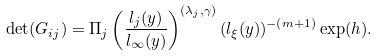<formula> <loc_0><loc_0><loc_500><loc_500>\det ( G _ { i j } ) = \Pi _ { j } \left ( \frac { l _ { j } ( y ) } { l _ { \infty } ( y ) } \right ) ^ { ( \lambda _ { j } , \gamma ) } ( l _ { \xi } ( y ) ) ^ { - ( m + 1 ) } \exp ( h ) .</formula> 